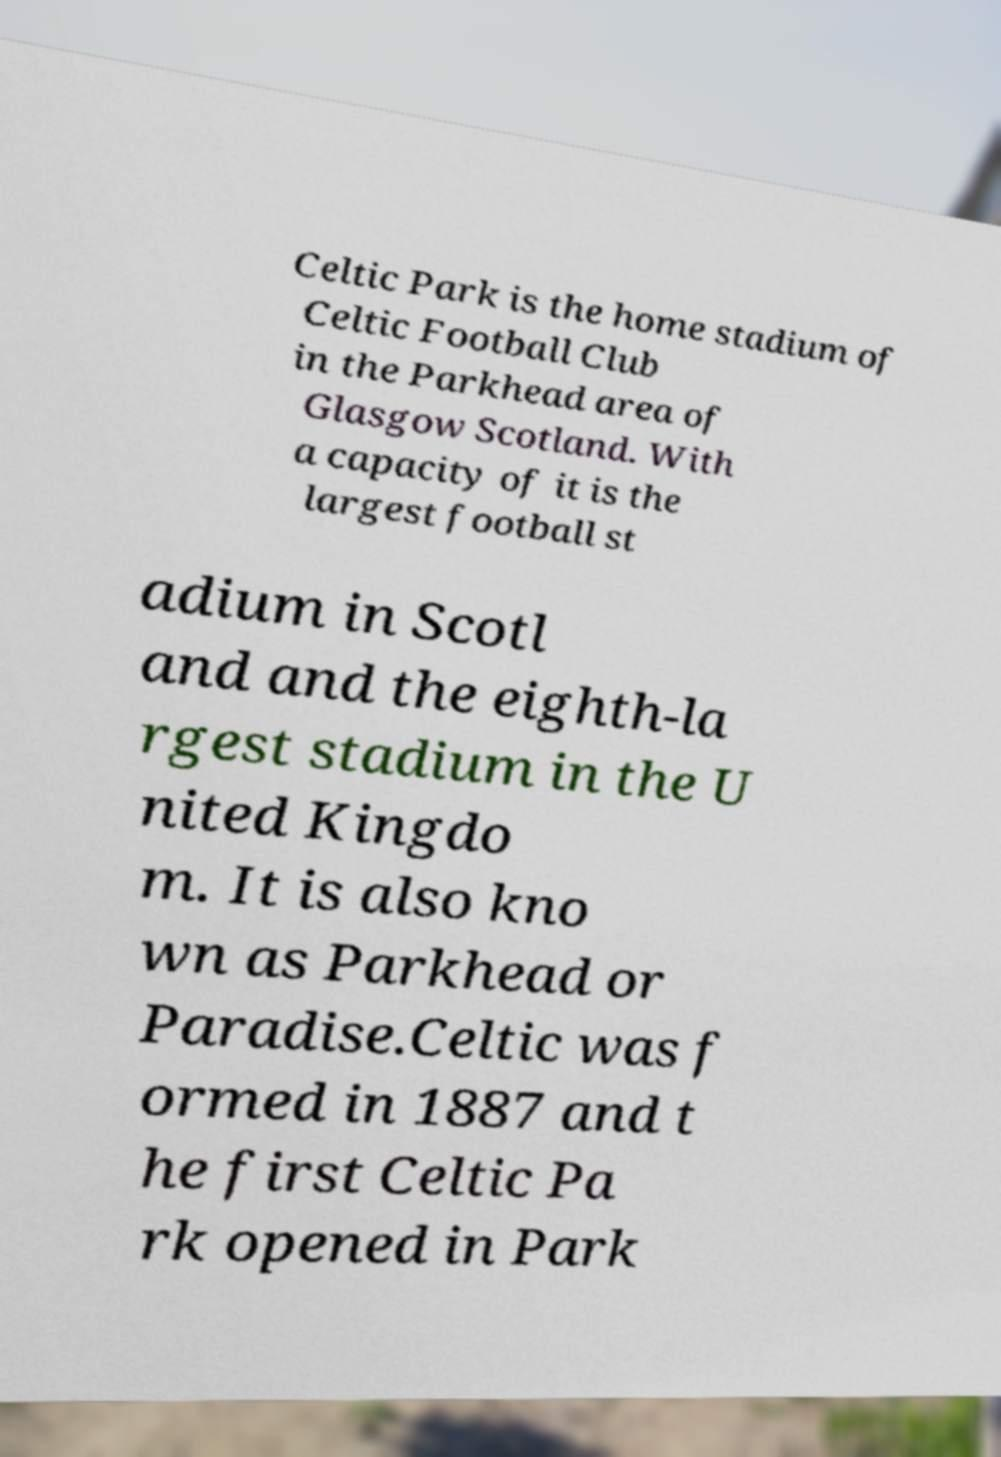For documentation purposes, I need the text within this image transcribed. Could you provide that? Celtic Park is the home stadium of Celtic Football Club in the Parkhead area of Glasgow Scotland. With a capacity of it is the largest football st adium in Scotl and and the eighth-la rgest stadium in the U nited Kingdo m. It is also kno wn as Parkhead or Paradise.Celtic was f ormed in 1887 and t he first Celtic Pa rk opened in Park 